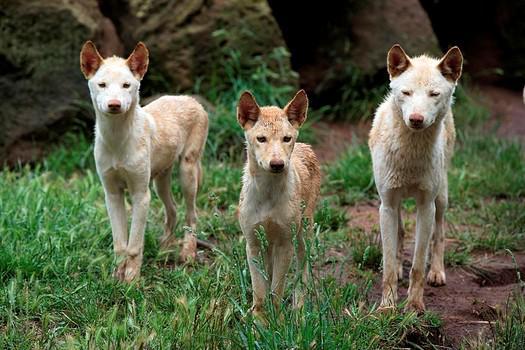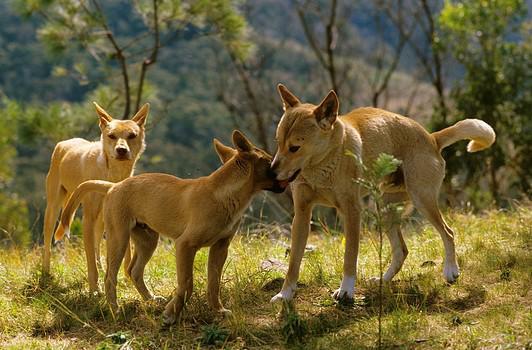The first image is the image on the left, the second image is the image on the right. Examine the images to the left and right. Is the description "There are two wolves  outside with at least one laying down in the dirt." accurate? Answer yes or no. No. The first image is the image on the left, the second image is the image on the right. Evaluate the accuracy of this statement regarding the images: "there are 2 wolves, one is in the back laying down under a shrub with willowy leaves, there is dirt under them with dead leaves on the ground". Is it true? Answer yes or no. No. 